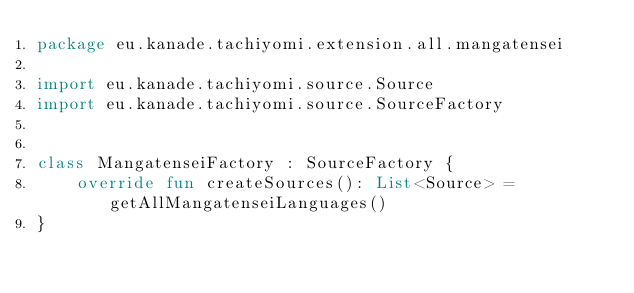Convert code to text. <code><loc_0><loc_0><loc_500><loc_500><_Kotlin_>package eu.kanade.tachiyomi.extension.all.mangatensei

import eu.kanade.tachiyomi.source.Source
import eu.kanade.tachiyomi.source.SourceFactory


class MangatenseiFactory : SourceFactory {
    override fun createSources(): List<Source> = getAllMangatenseiLanguages()
}</code> 